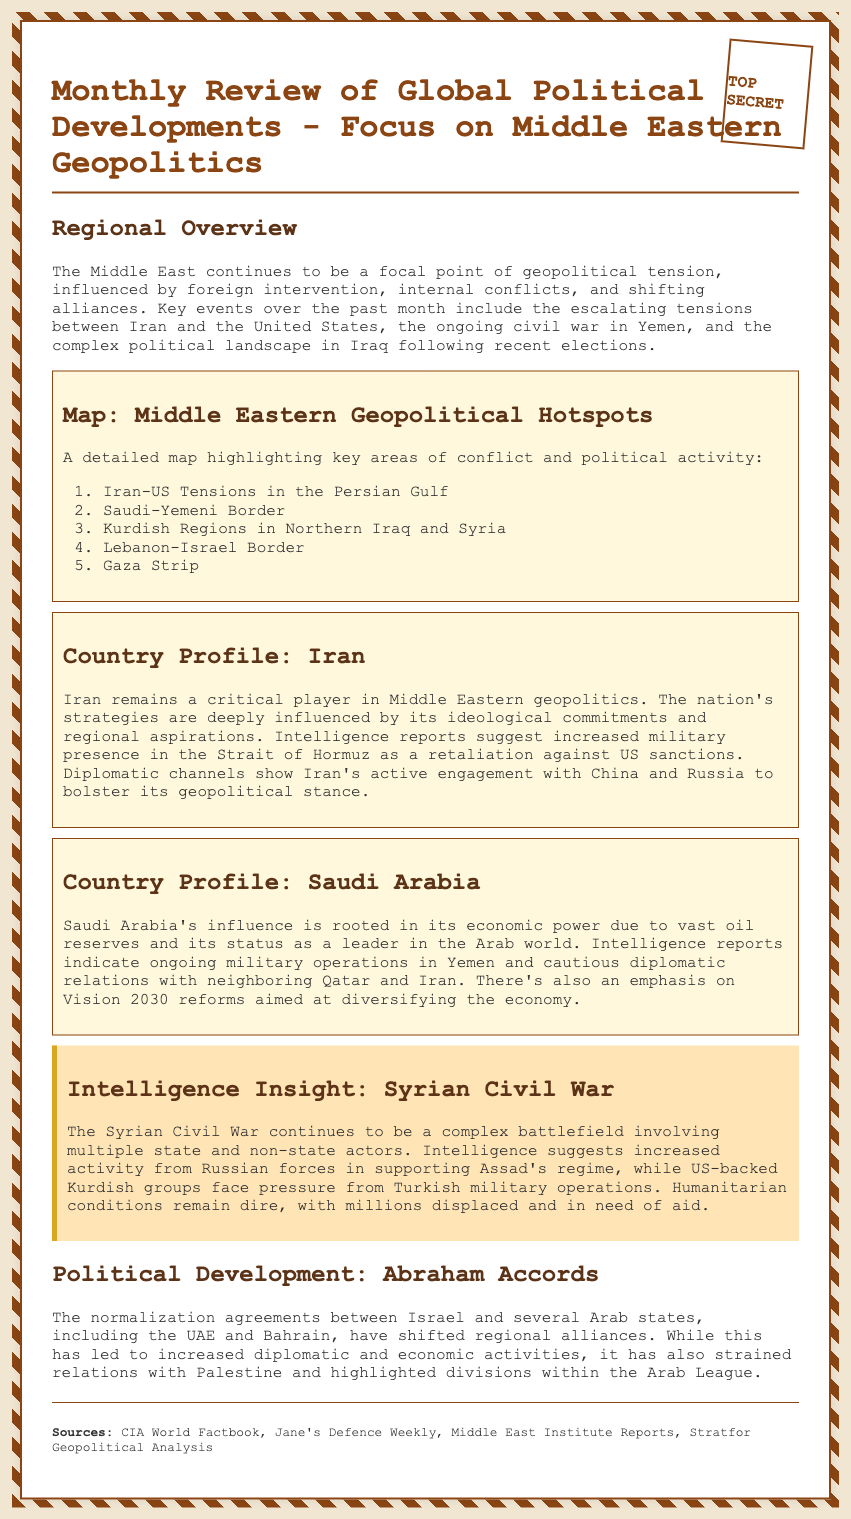what is the title of the document? The title of the document is stated prominently at the top, introducing its main focus.
Answer: Monthly Review of Global Political Developments - Focus on Middle Eastern Geopolitics how many key areas of conflict are highlighted in the map? The number of key areas of conflict is listed in the ordered list provided under the map section.
Answer: five which country is involved in military operations in Yemen? The country profile section discusses the military actions of Saudi Arabia specifically related to Yemen.
Answer: Saudi Arabia what does Iran seek to bolster its geopolitical stance? The country profile for Iran outlines its diplomatic efforts to engage with certain nations for support.
Answer: China and Russia what does the document mention about the Abraham Accords? The document describes the impact and implications of the Abraham Accords on regional relations.
Answer: Shifted regional alliances which region faces dire humanitarian conditions according to the intelligence insight? The intelligence insight section specifically mentions the humanitarian situation in a particular country affected by conflict.
Answer: Syrian Civil War 